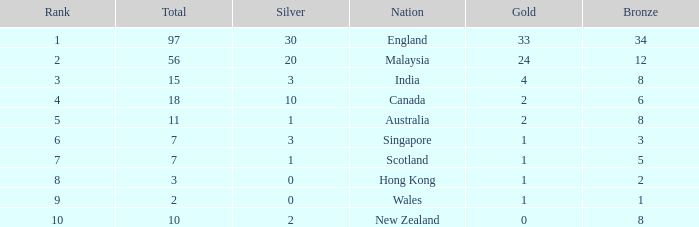What is the number of bronze that Scotland, which has less than 7 total medals, has? None. 